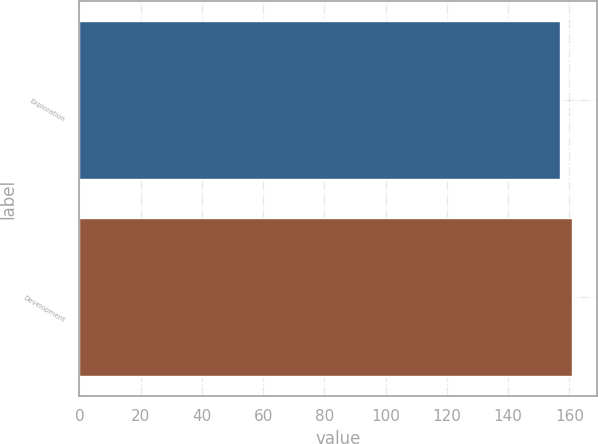Convert chart to OTSL. <chart><loc_0><loc_0><loc_500><loc_500><bar_chart><fcel>Exploration<fcel>Development<nl><fcel>157<fcel>161<nl></chart> 